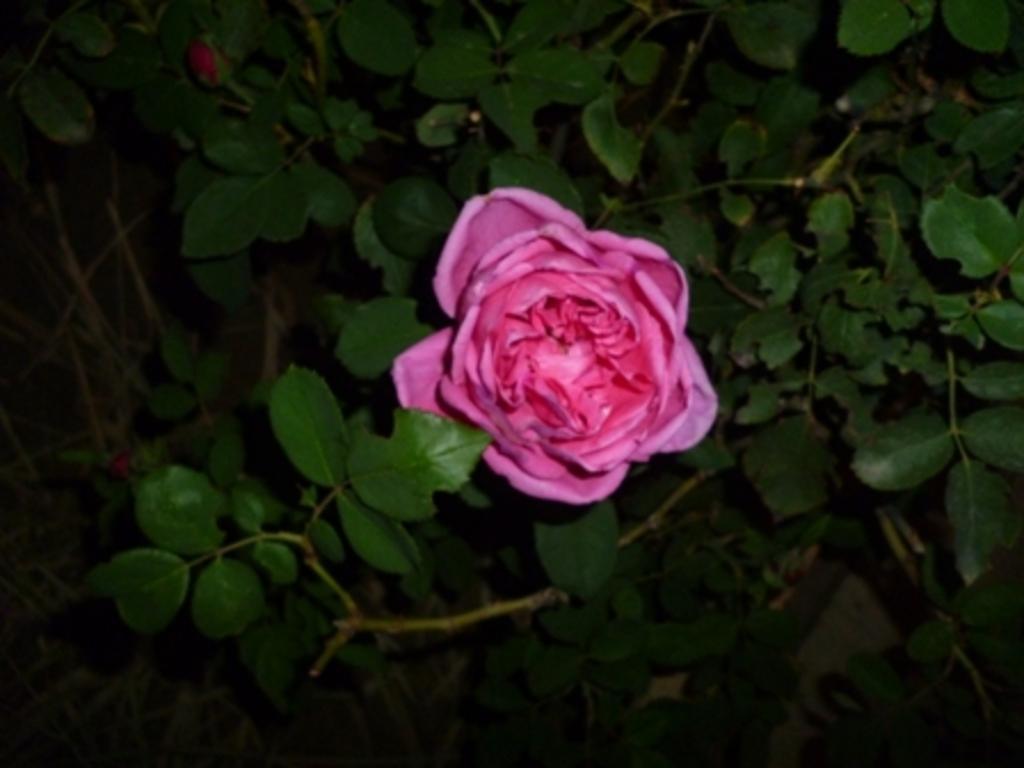How would you summarize this image in a sentence or two? In this image we can able to see a pink rose and a flower bud, and there are some plants around it. 